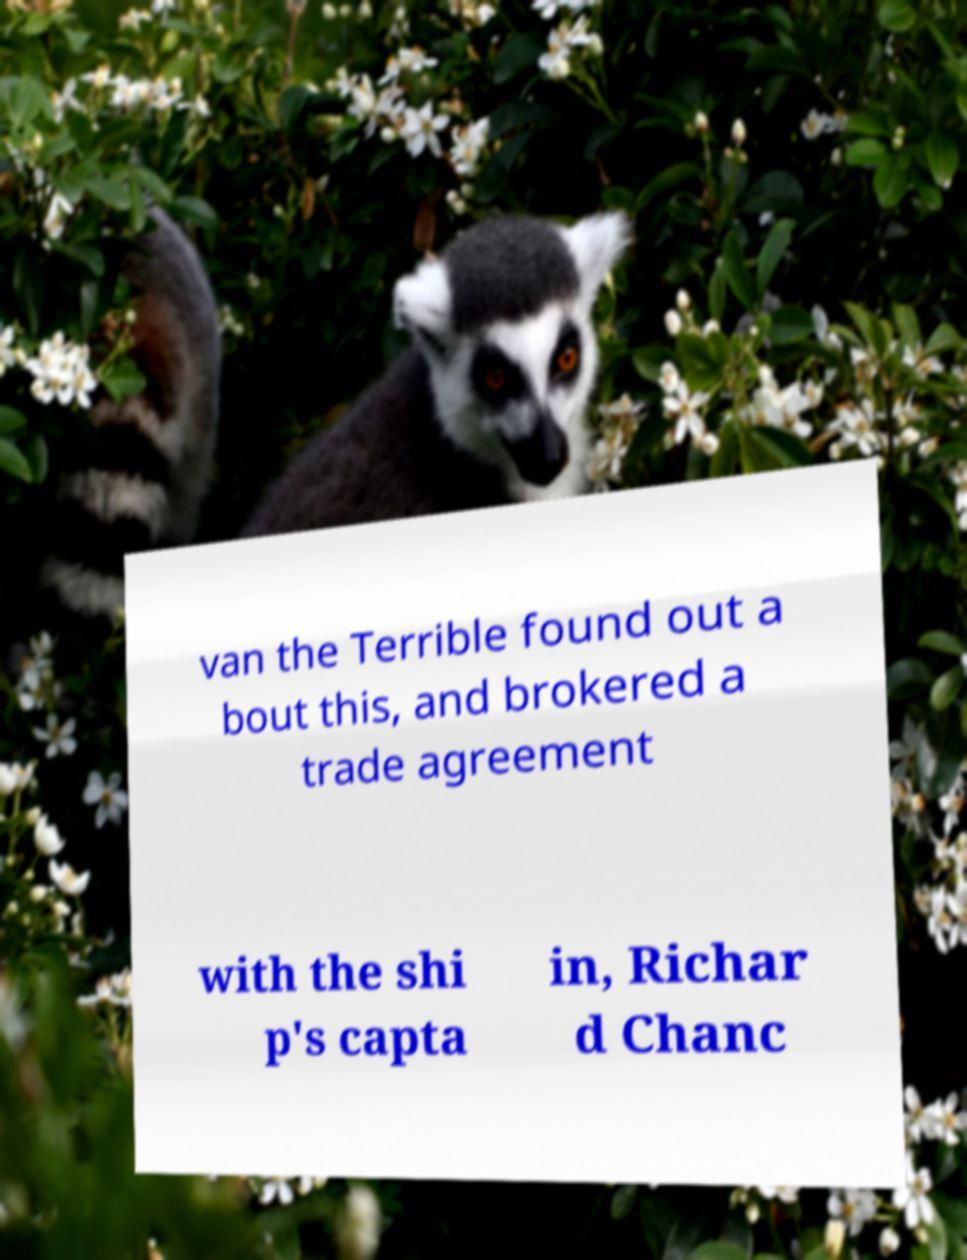There's text embedded in this image that I need extracted. Can you transcribe it verbatim? van the Terrible found out a bout this, and brokered a trade agreement with the shi p's capta in, Richar d Chanc 